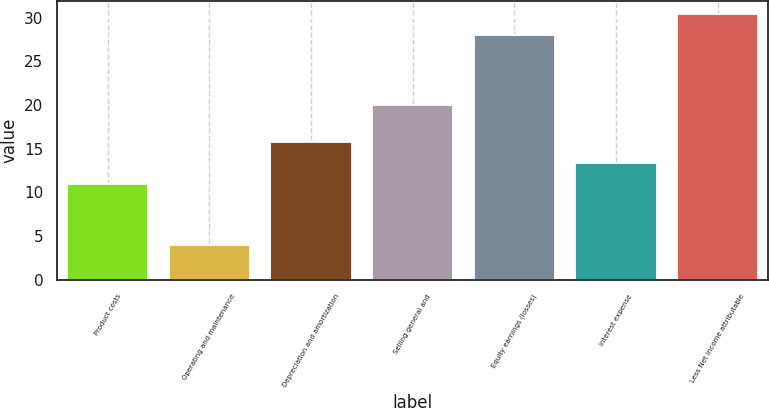<chart> <loc_0><loc_0><loc_500><loc_500><bar_chart><fcel>Product costs<fcel>Operating and maintenance<fcel>Depreciation and amortization<fcel>Selling general and<fcel>Equity earnings (losses)<fcel>Interest expense<fcel>Less Net income attributable<nl><fcel>11<fcel>4<fcel>15.8<fcel>20<fcel>28<fcel>13.4<fcel>30.4<nl></chart> 